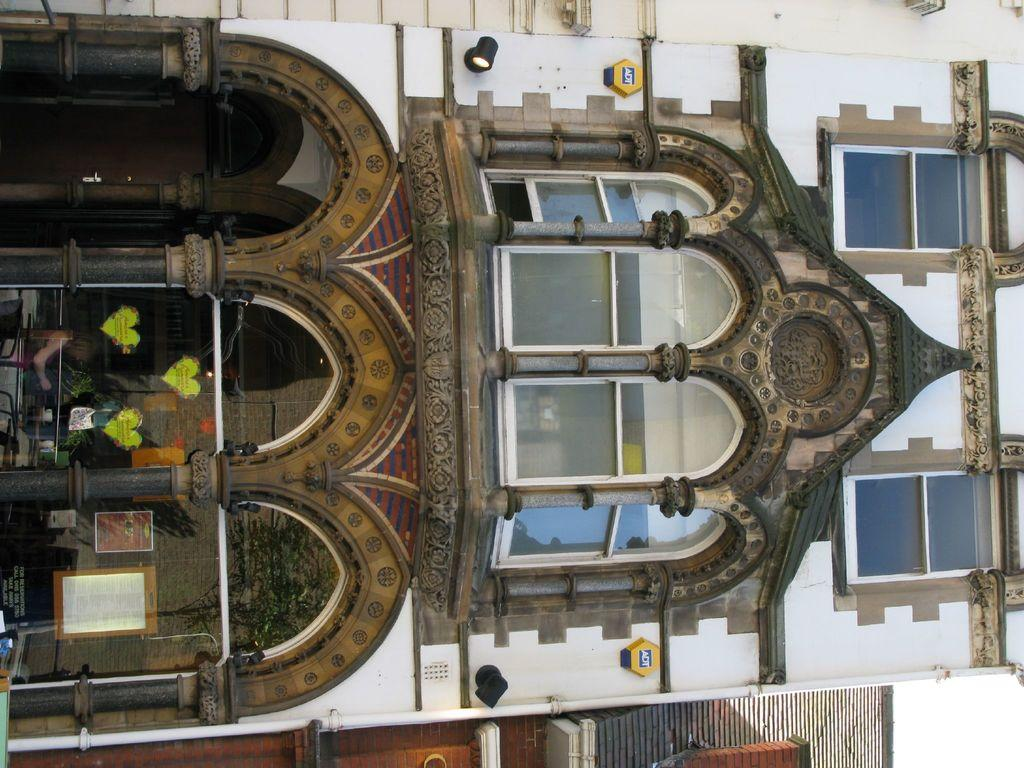How is the image oriented? The image is tilted. What type of structure can be seen in the image? There is a building in the image. What material are the windows of the building made of? The building has glass windows. What is the skin condition of the building in the image? There is no concept of skin condition applicable to a building, as it is a non-living structure. 